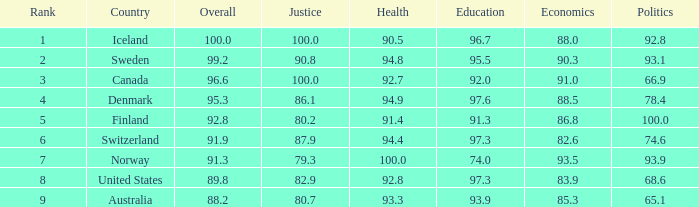What's the economics score with education being 92.0 91.0. 